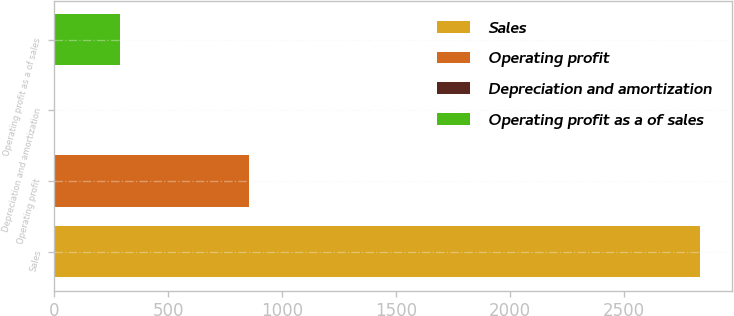Convert chart. <chart><loc_0><loc_0><loc_500><loc_500><bar_chart><fcel>Sales<fcel>Operating profit<fcel>Depreciation and amortization<fcel>Operating profit as a of sales<nl><fcel>2832.9<fcel>852.53<fcel>3.8<fcel>286.71<nl></chart> 